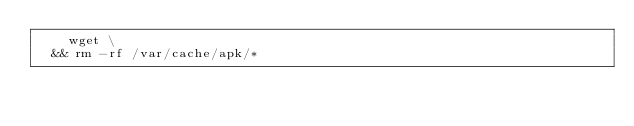<code> <loc_0><loc_0><loc_500><loc_500><_Dockerfile_>		wget \
	&& rm -rf /var/cache/apk/*
</code> 